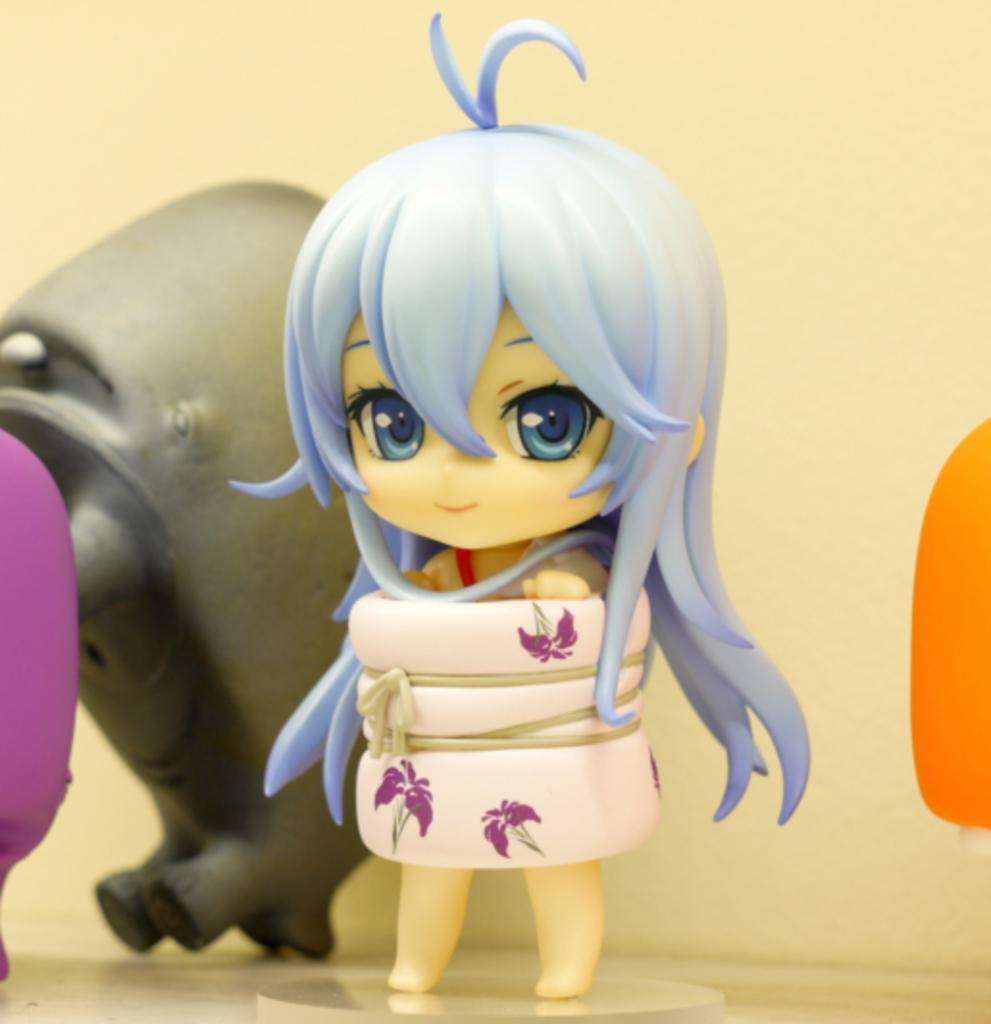What objects are present in the image? There are toys in the image. What is the color of the surface on which the toys are placed? The toys are on a white surface. What can be seen in the background of the image? There is a wall in the background of the image. What advice does the manager give to the aunt in the image? There is no manager or aunt present in the image, so it is not possible to answer that question. 